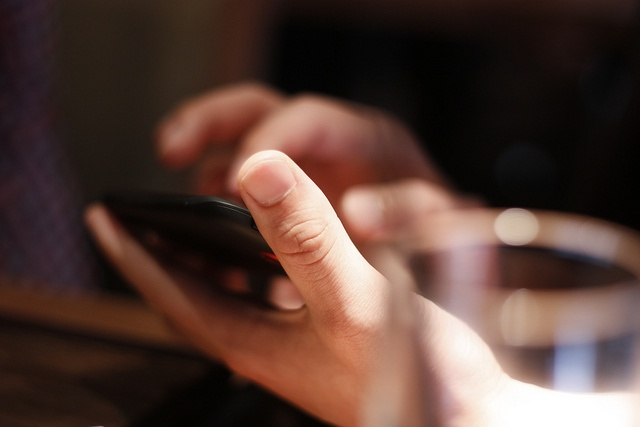Describe the objects in this image and their specific colors. I can see people in black, brown, maroon, and white tones and cell phone in black, maroon, and brown tones in this image. 